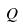<formula> <loc_0><loc_0><loc_500><loc_500>Q</formula> 